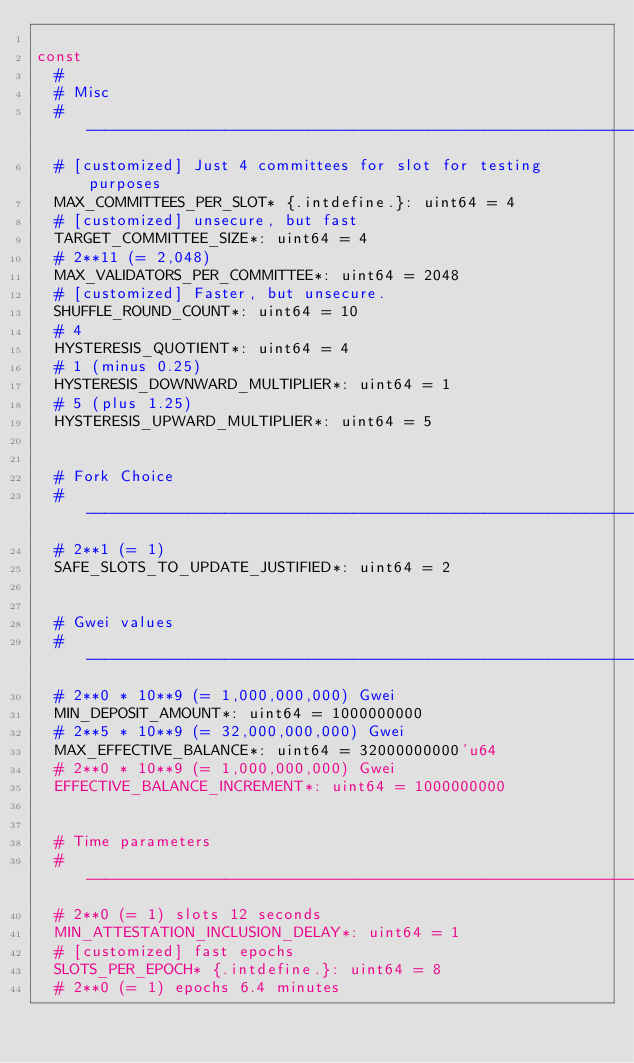Convert code to text. <code><loc_0><loc_0><loc_500><loc_500><_Nim_>
const
  #
  # Misc
  # ---------------------------------------------------------------
  # [customized] Just 4 committees for slot for testing purposes
  MAX_COMMITTEES_PER_SLOT* {.intdefine.}: uint64 = 4
  # [customized] unsecure, but fast
  TARGET_COMMITTEE_SIZE*: uint64 = 4
  # 2**11 (= 2,048)
  MAX_VALIDATORS_PER_COMMITTEE*: uint64 = 2048
  # [customized] Faster, but unsecure.
  SHUFFLE_ROUND_COUNT*: uint64 = 10
  # 4
  HYSTERESIS_QUOTIENT*: uint64 = 4
  # 1 (minus 0.25)
  HYSTERESIS_DOWNWARD_MULTIPLIER*: uint64 = 1
  # 5 (plus 1.25)
  HYSTERESIS_UPWARD_MULTIPLIER*: uint64 = 5


  # Fork Choice
  # ---------------------------------------------------------------
  # 2**1 (= 1)
  SAFE_SLOTS_TO_UPDATE_JUSTIFIED*: uint64 = 2


  # Gwei values
  # ---------------------------------------------------------------
  # 2**0 * 10**9 (= 1,000,000,000) Gwei
  MIN_DEPOSIT_AMOUNT*: uint64 = 1000000000
  # 2**5 * 10**9 (= 32,000,000,000) Gwei
  MAX_EFFECTIVE_BALANCE*: uint64 = 32000000000'u64
  # 2**0 * 10**9 (= 1,000,000,000) Gwei
  EFFECTIVE_BALANCE_INCREMENT*: uint64 = 1000000000


  # Time parameters
  # ---------------------------------------------------------------
  # 2**0 (= 1) slots 12 seconds
  MIN_ATTESTATION_INCLUSION_DELAY*: uint64 = 1
  # [customized] fast epochs
  SLOTS_PER_EPOCH* {.intdefine.}: uint64 = 8
  # 2**0 (= 1) epochs 6.4 minutes</code> 